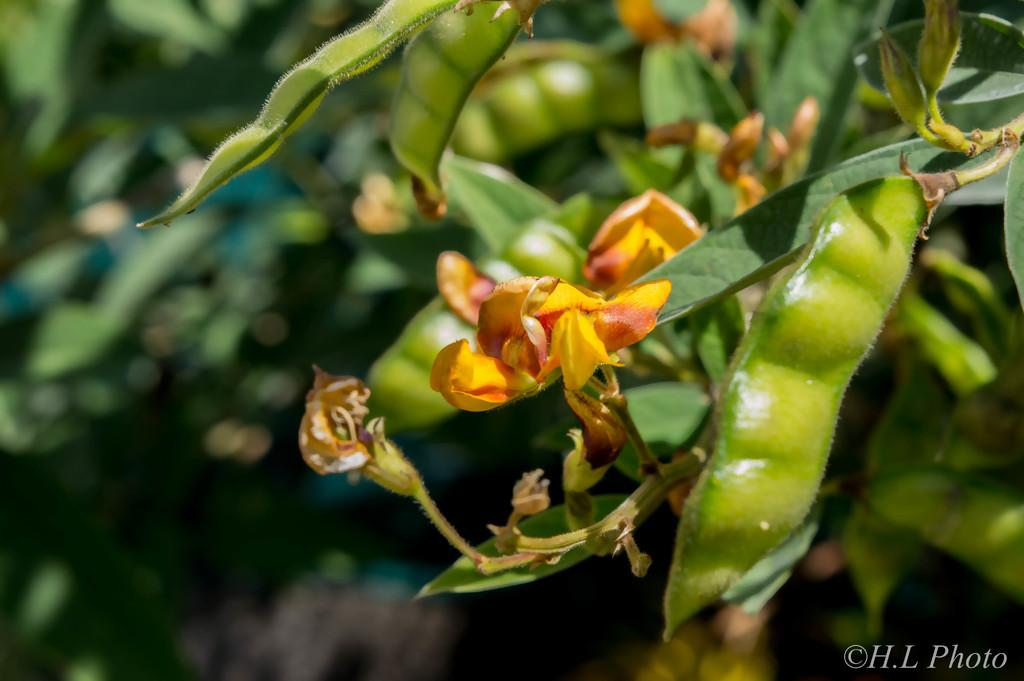What type of tree is in the image? There is a beans tree in the image. Are there any flowers on the tree? Yes, there is a flower on the tree. Can you describe the background of the image? The background of the image is blurry. How many legs does the government have in the image? There is no government present in the image, so it is not possible to determine how many legs it might have. 